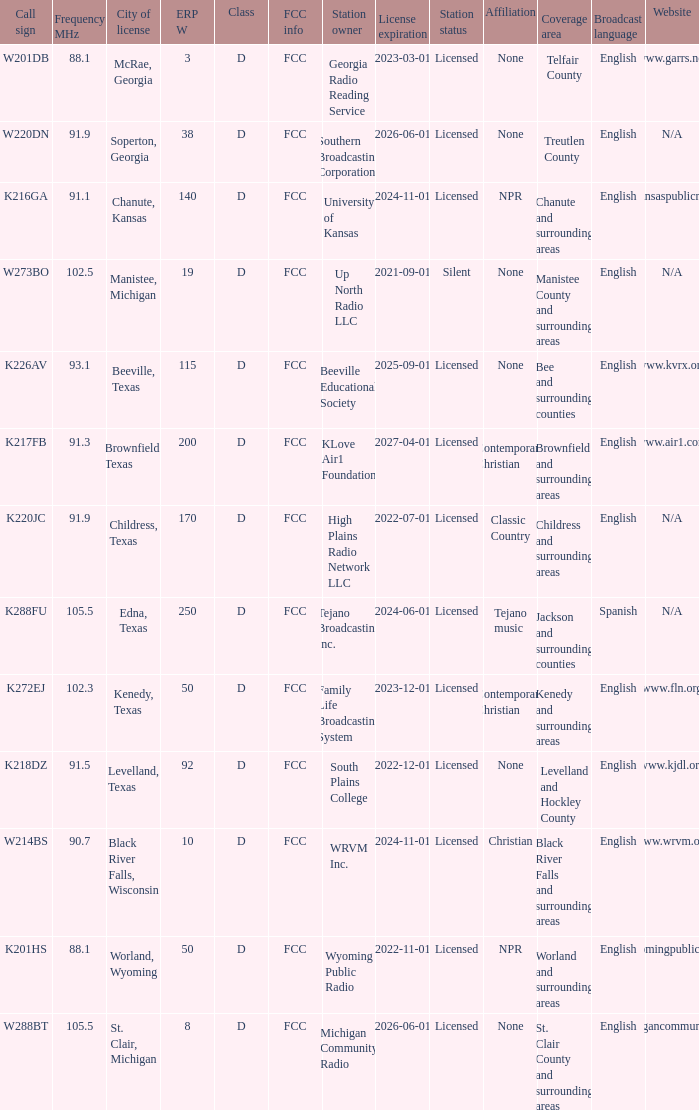What is the Sum of ERP W, when Call Sign is K216GA? 140.0. 